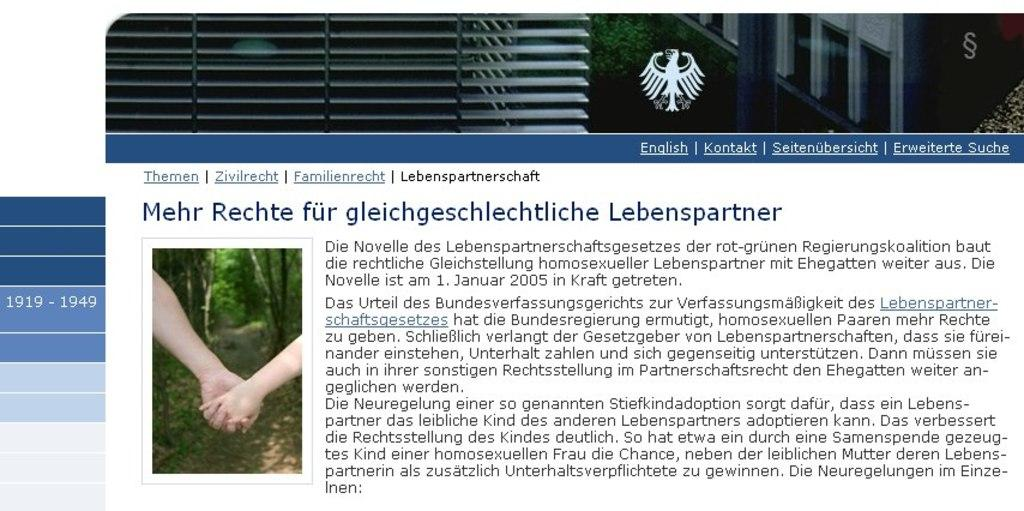What is the main subject of the image? The main subject of the image is a web page. What can be seen on the web page? There is some text visible on the web page. What type of hair can be seen on the web page in the image? There is no hair present on the web page in the image, as it is a digital representation of a web page. What type of crime is being committed on the web page in the image? There is no crime present on the web page in the image, as it is a digital representation of a web page. 